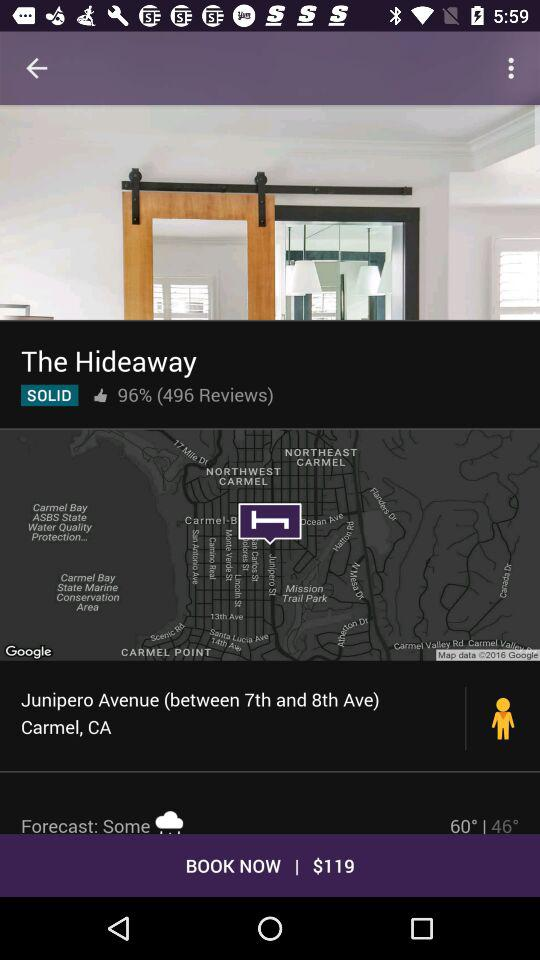How many reviews does "The Hideaway" have? "The Hideaway" has 496 reviews. 